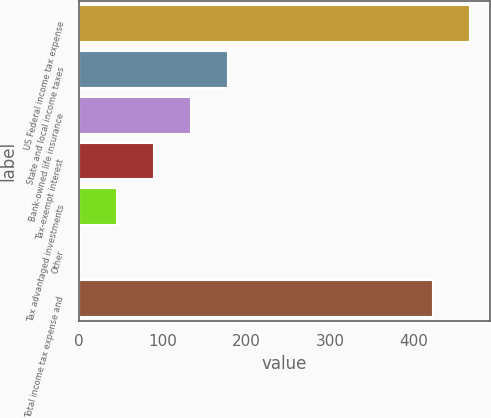Convert chart to OTSL. <chart><loc_0><loc_0><loc_500><loc_500><bar_chart><fcel>US Federal income tax expense<fcel>State and local income taxes<fcel>Bank-owned life insurance<fcel>Tax-exempt interest<fcel>Tax advantaged investments<fcel>Other<fcel>Total income tax expense and<nl><fcel>467.1<fcel>177.4<fcel>133.3<fcel>89.2<fcel>45.1<fcel>1<fcel>423<nl></chart> 